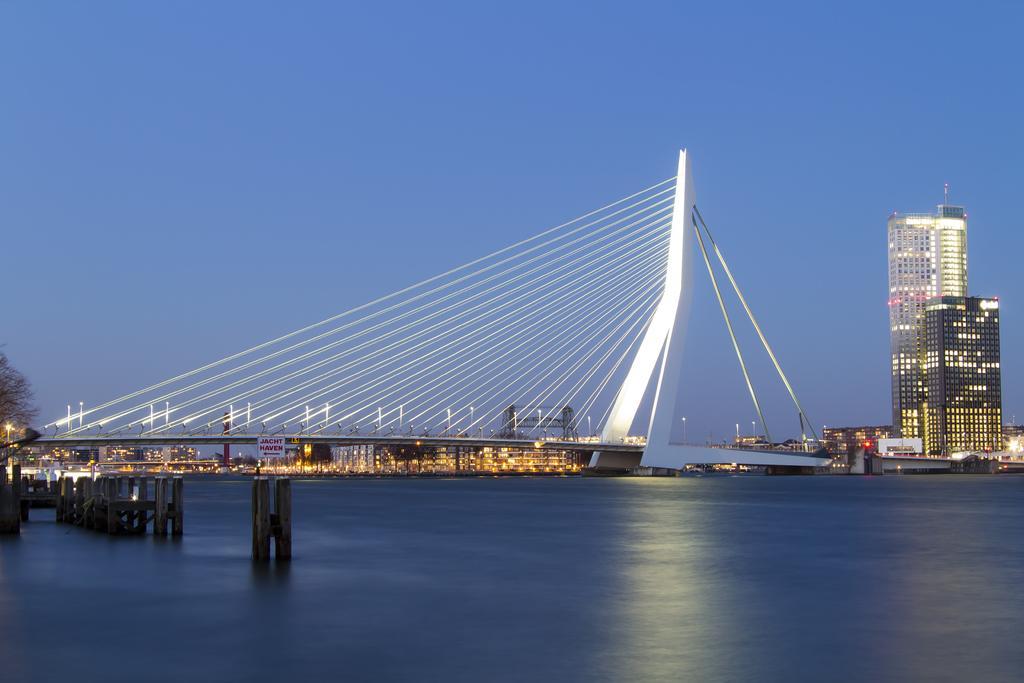How would you summarize this image in a sentence or two? This image consists of a bridge. At the bottom, there is water. On the right, we can see skyscrapers. At the top, there is sky. 